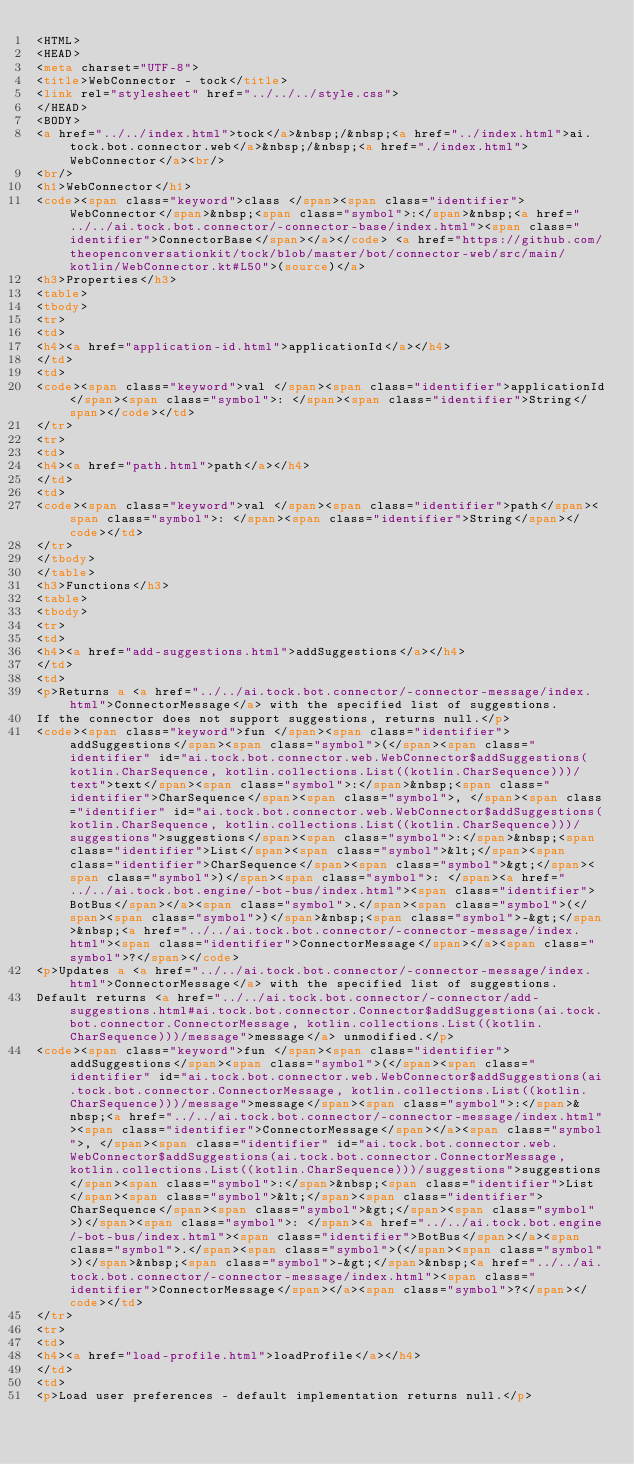Convert code to text. <code><loc_0><loc_0><loc_500><loc_500><_HTML_><HTML>
<HEAD>
<meta charset="UTF-8">
<title>WebConnector - tock</title>
<link rel="stylesheet" href="../../../style.css">
</HEAD>
<BODY>
<a href="../../index.html">tock</a>&nbsp;/&nbsp;<a href="../index.html">ai.tock.bot.connector.web</a>&nbsp;/&nbsp;<a href="./index.html">WebConnector</a><br/>
<br/>
<h1>WebConnector</h1>
<code><span class="keyword">class </span><span class="identifier">WebConnector</span>&nbsp;<span class="symbol">:</span>&nbsp;<a href="../../ai.tock.bot.connector/-connector-base/index.html"><span class="identifier">ConnectorBase</span></a></code> <a href="https://github.com/theopenconversationkit/tock/blob/master/bot/connector-web/src/main/kotlin/WebConnector.kt#L50">(source)</a>
<h3>Properties</h3>
<table>
<tbody>
<tr>
<td>
<h4><a href="application-id.html">applicationId</a></h4>
</td>
<td>
<code><span class="keyword">val </span><span class="identifier">applicationId</span><span class="symbol">: </span><span class="identifier">String</span></code></td>
</tr>
<tr>
<td>
<h4><a href="path.html">path</a></h4>
</td>
<td>
<code><span class="keyword">val </span><span class="identifier">path</span><span class="symbol">: </span><span class="identifier">String</span></code></td>
</tr>
</tbody>
</table>
<h3>Functions</h3>
<table>
<tbody>
<tr>
<td>
<h4><a href="add-suggestions.html">addSuggestions</a></h4>
</td>
<td>
<p>Returns a <a href="../../ai.tock.bot.connector/-connector-message/index.html">ConnectorMessage</a> with the specified list of suggestions.
If the connector does not support suggestions, returns null.</p>
<code><span class="keyword">fun </span><span class="identifier">addSuggestions</span><span class="symbol">(</span><span class="identifier" id="ai.tock.bot.connector.web.WebConnector$addSuggestions(kotlin.CharSequence, kotlin.collections.List((kotlin.CharSequence)))/text">text</span><span class="symbol">:</span>&nbsp;<span class="identifier">CharSequence</span><span class="symbol">, </span><span class="identifier" id="ai.tock.bot.connector.web.WebConnector$addSuggestions(kotlin.CharSequence, kotlin.collections.List((kotlin.CharSequence)))/suggestions">suggestions</span><span class="symbol">:</span>&nbsp;<span class="identifier">List</span><span class="symbol">&lt;</span><span class="identifier">CharSequence</span><span class="symbol">&gt;</span><span class="symbol">)</span><span class="symbol">: </span><a href="../../ai.tock.bot.engine/-bot-bus/index.html"><span class="identifier">BotBus</span></a><span class="symbol">.</span><span class="symbol">(</span><span class="symbol">)</span>&nbsp;<span class="symbol">-&gt;</span>&nbsp;<a href="../../ai.tock.bot.connector/-connector-message/index.html"><span class="identifier">ConnectorMessage</span></a><span class="symbol">?</span></code>
<p>Updates a <a href="../../ai.tock.bot.connector/-connector-message/index.html">ConnectorMessage</a> with the specified list of suggestions.
Default returns <a href="../../ai.tock.bot.connector/-connector/add-suggestions.html#ai.tock.bot.connector.Connector$addSuggestions(ai.tock.bot.connector.ConnectorMessage, kotlin.collections.List((kotlin.CharSequence)))/message">message</a> unmodified.</p>
<code><span class="keyword">fun </span><span class="identifier">addSuggestions</span><span class="symbol">(</span><span class="identifier" id="ai.tock.bot.connector.web.WebConnector$addSuggestions(ai.tock.bot.connector.ConnectorMessage, kotlin.collections.List((kotlin.CharSequence)))/message">message</span><span class="symbol">:</span>&nbsp;<a href="../../ai.tock.bot.connector/-connector-message/index.html"><span class="identifier">ConnectorMessage</span></a><span class="symbol">, </span><span class="identifier" id="ai.tock.bot.connector.web.WebConnector$addSuggestions(ai.tock.bot.connector.ConnectorMessage, kotlin.collections.List((kotlin.CharSequence)))/suggestions">suggestions</span><span class="symbol">:</span>&nbsp;<span class="identifier">List</span><span class="symbol">&lt;</span><span class="identifier">CharSequence</span><span class="symbol">&gt;</span><span class="symbol">)</span><span class="symbol">: </span><a href="../../ai.tock.bot.engine/-bot-bus/index.html"><span class="identifier">BotBus</span></a><span class="symbol">.</span><span class="symbol">(</span><span class="symbol">)</span>&nbsp;<span class="symbol">-&gt;</span>&nbsp;<a href="../../ai.tock.bot.connector/-connector-message/index.html"><span class="identifier">ConnectorMessage</span></a><span class="symbol">?</span></code></td>
</tr>
<tr>
<td>
<h4><a href="load-profile.html">loadProfile</a></h4>
</td>
<td>
<p>Load user preferences - default implementation returns null.</p></code> 